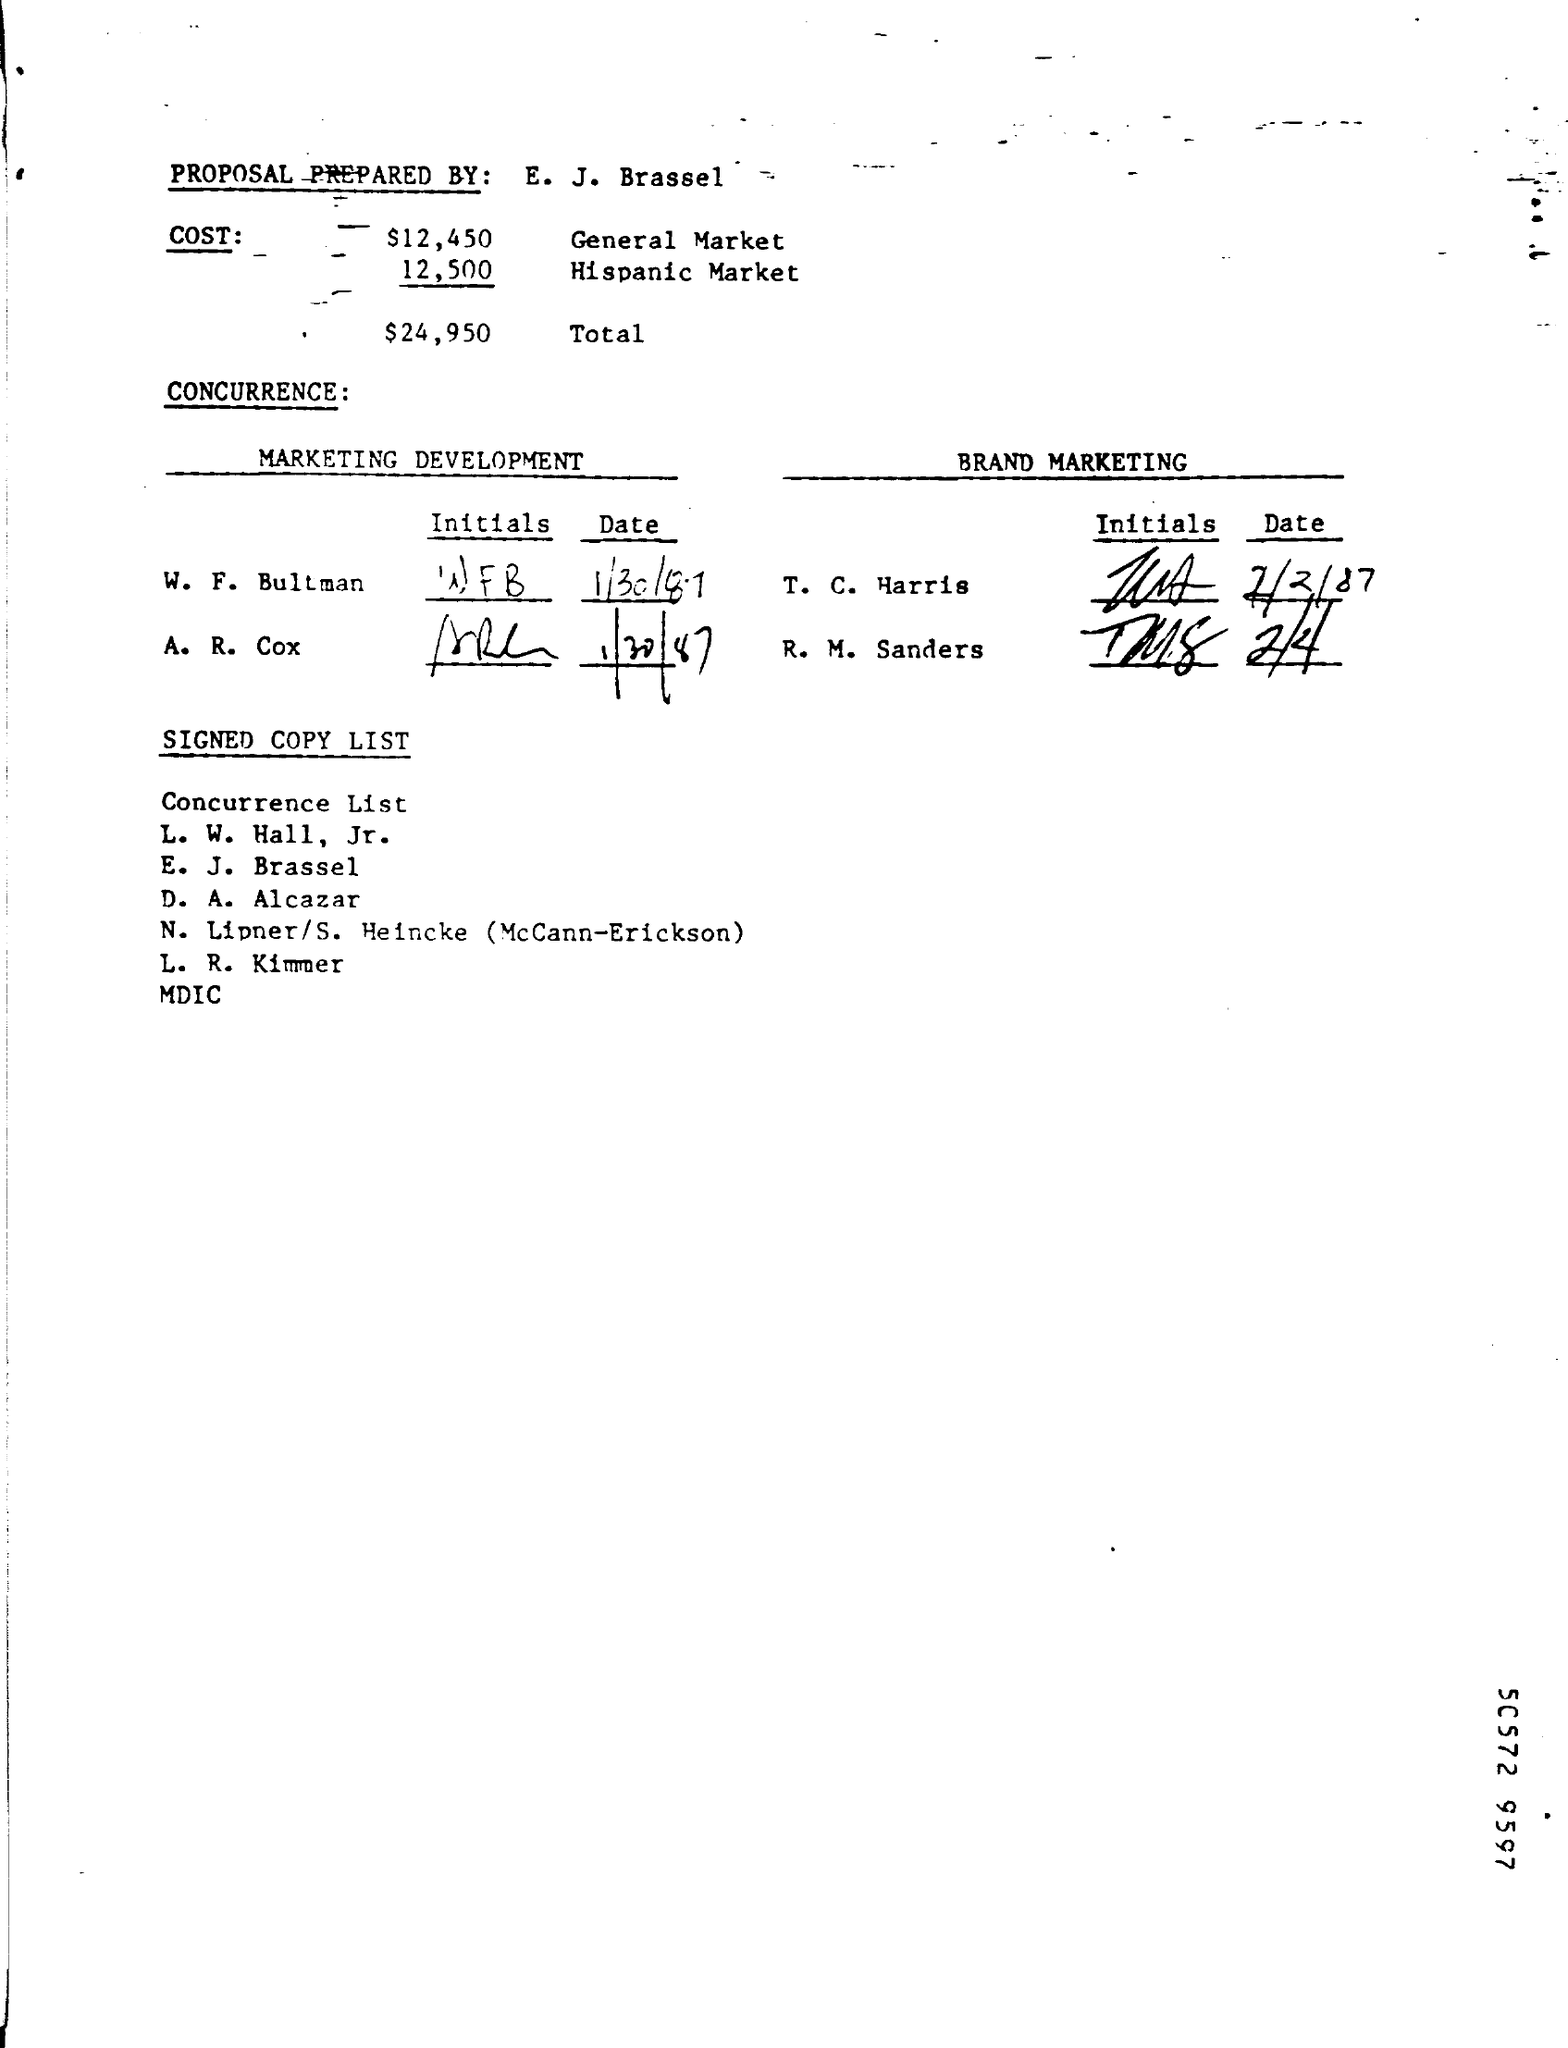Indicate a few pertinent items in this graphic. The Hispanic market cost is $12,500. The total cost of the proposal is $24,950. The date of marketing development completed by W. F. Bultman is January 30, 1987. The PROPOSAL was prepared by E. J. Brassel. 